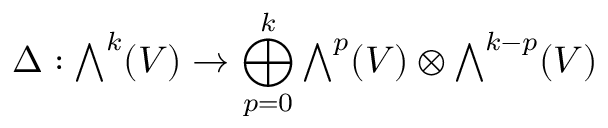<formula> <loc_0><loc_0><loc_500><loc_500>\Delta \colon { \bigwedge } ^ { k } ( V ) \to \bigoplus _ { p = 0 } ^ { k } { \bigwedge } ^ { p } ( V ) \otimes { \bigwedge } ^ { k - p } ( V )</formula> 